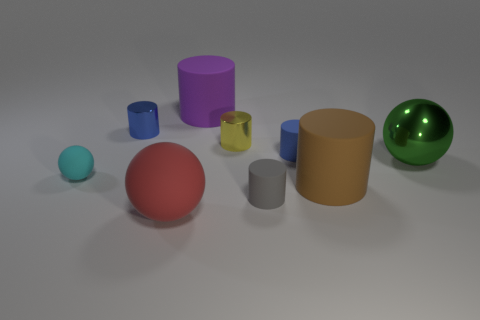Subtract 1 cylinders. How many cylinders are left? 5 Subtract all brown cylinders. How many cylinders are left? 5 Subtract all small rubber cylinders. How many cylinders are left? 4 Subtract all gray cylinders. Subtract all red blocks. How many cylinders are left? 5 Add 1 tiny yellow metal cubes. How many objects exist? 10 Subtract all cylinders. How many objects are left? 3 Add 4 small blue rubber cylinders. How many small blue rubber cylinders are left? 5 Add 1 large shiny balls. How many large shiny balls exist? 2 Subtract 0 yellow balls. How many objects are left? 9 Subtract all purple matte things. Subtract all blue things. How many objects are left? 6 